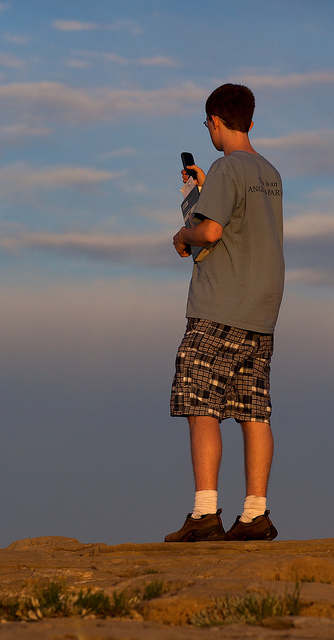<image>What does the man's short say? I don't know what the man's shirt says. It seems to be not clear. What does the man's short say? I am not sure what the man's shirt says. It can be seen as 'gibberish', 'nothing', 'retro', 'op', or 'tunic'. 